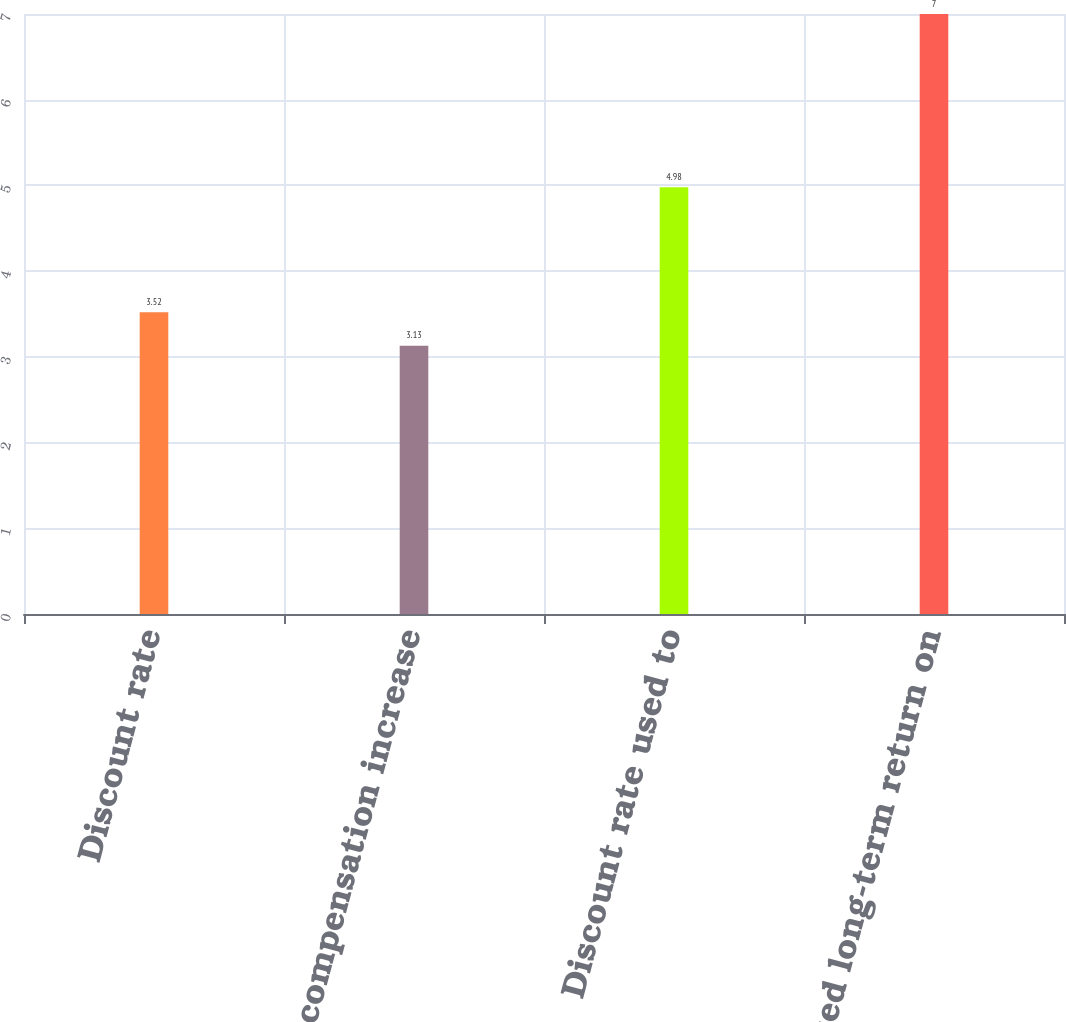Convert chart to OTSL. <chart><loc_0><loc_0><loc_500><loc_500><bar_chart><fcel>Discount rate<fcel>Rate of compensation increase<fcel>Discount rate used to<fcel>Expected long-term return on<nl><fcel>3.52<fcel>3.13<fcel>4.98<fcel>7<nl></chart> 